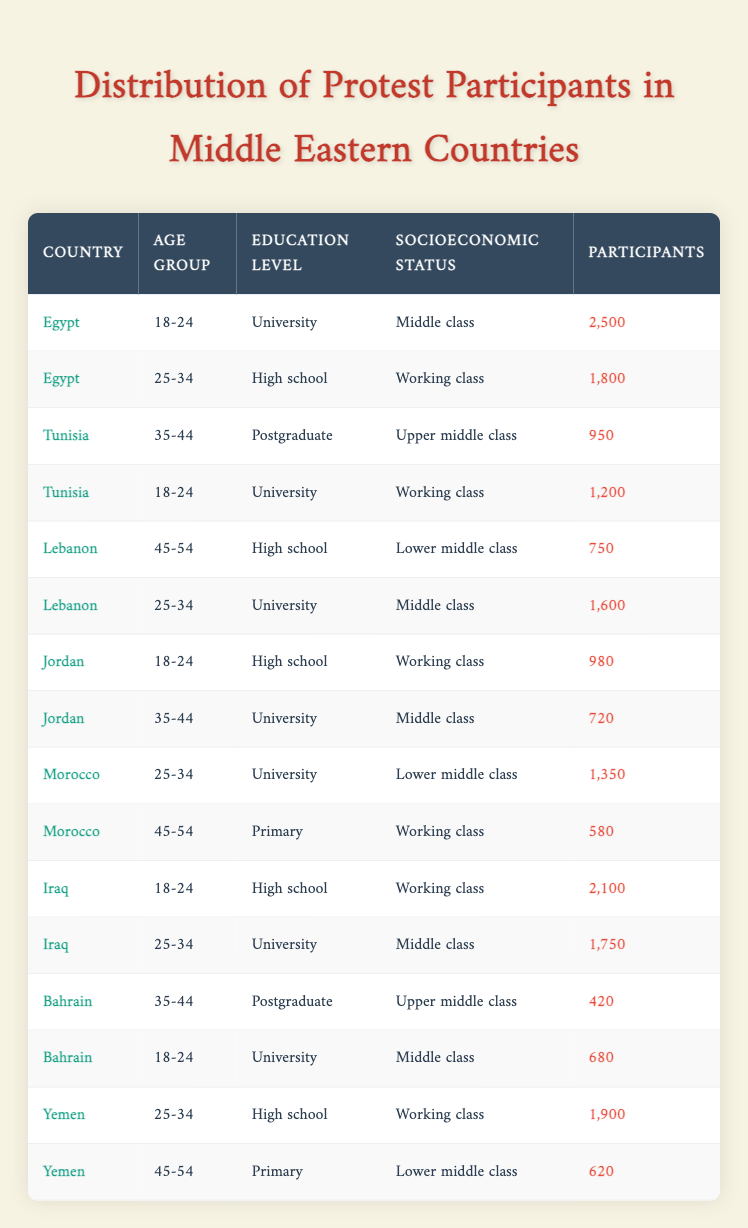What is the total number of participants from Egypt? From the table, there are two entries for Egypt: 2,500 participants in the age group 18-24 and 1,800 participants in the age group 25-34. To find the total number of participants, we sum these values: 2,500 + 1,800 = 4,300.
Answer: 4,300 Which age group has the highest number of participants in Tunisia? Tunisia has two entries: 1,200 participants in the age group 18-24 and 950 participants in the age group 35-44. The age group with the highest number of participants is clearly the 18-24 group since 1,200 is greater than 950.
Answer: 18-24 Are there more participants from the upper middle class or the working class in Bahrain? Bahrain has 680 participants from the middle class (age 18-24, education University) and 420 participants from the upper middle class (age 35-44, education Postgraduate). Since 680 (middle class) is greater than 420 (upper middle class), the answer is yes, there are more participants from the middle class.
Answer: Yes What is the average number of participants for the age group 25-34 across all countries? We need to find the number of participants in the age group 25-34 from each country: Egypt (1,800), Tunisia (1,200), Lebanon (1,600), Morocco (1,350), Iraq (1,750), Yemen (1,900). Adding these gives us a total of 1,800 + 1,200 + 1,600 + 1,350 + 1,750 + 1,900 = 9,600. There are six entries, so the average is 9,600 divided by 6, which equals 1,600.
Answer: 1,600 Which country has the fewest total protest participants in all age groups combined? First, we sum the participants for each country: Egypt (4,300), Tunisia (2,150), Lebanon (2,350), Jordan (1,700), Morocco (1,930), Iraq (3,850), Bahrain (1,100), and Yemen (2,520). The minimum total participants is in Bahrain with 1,100 participants. Thus, Bahrain has the fewest.
Answer: Bahrain 